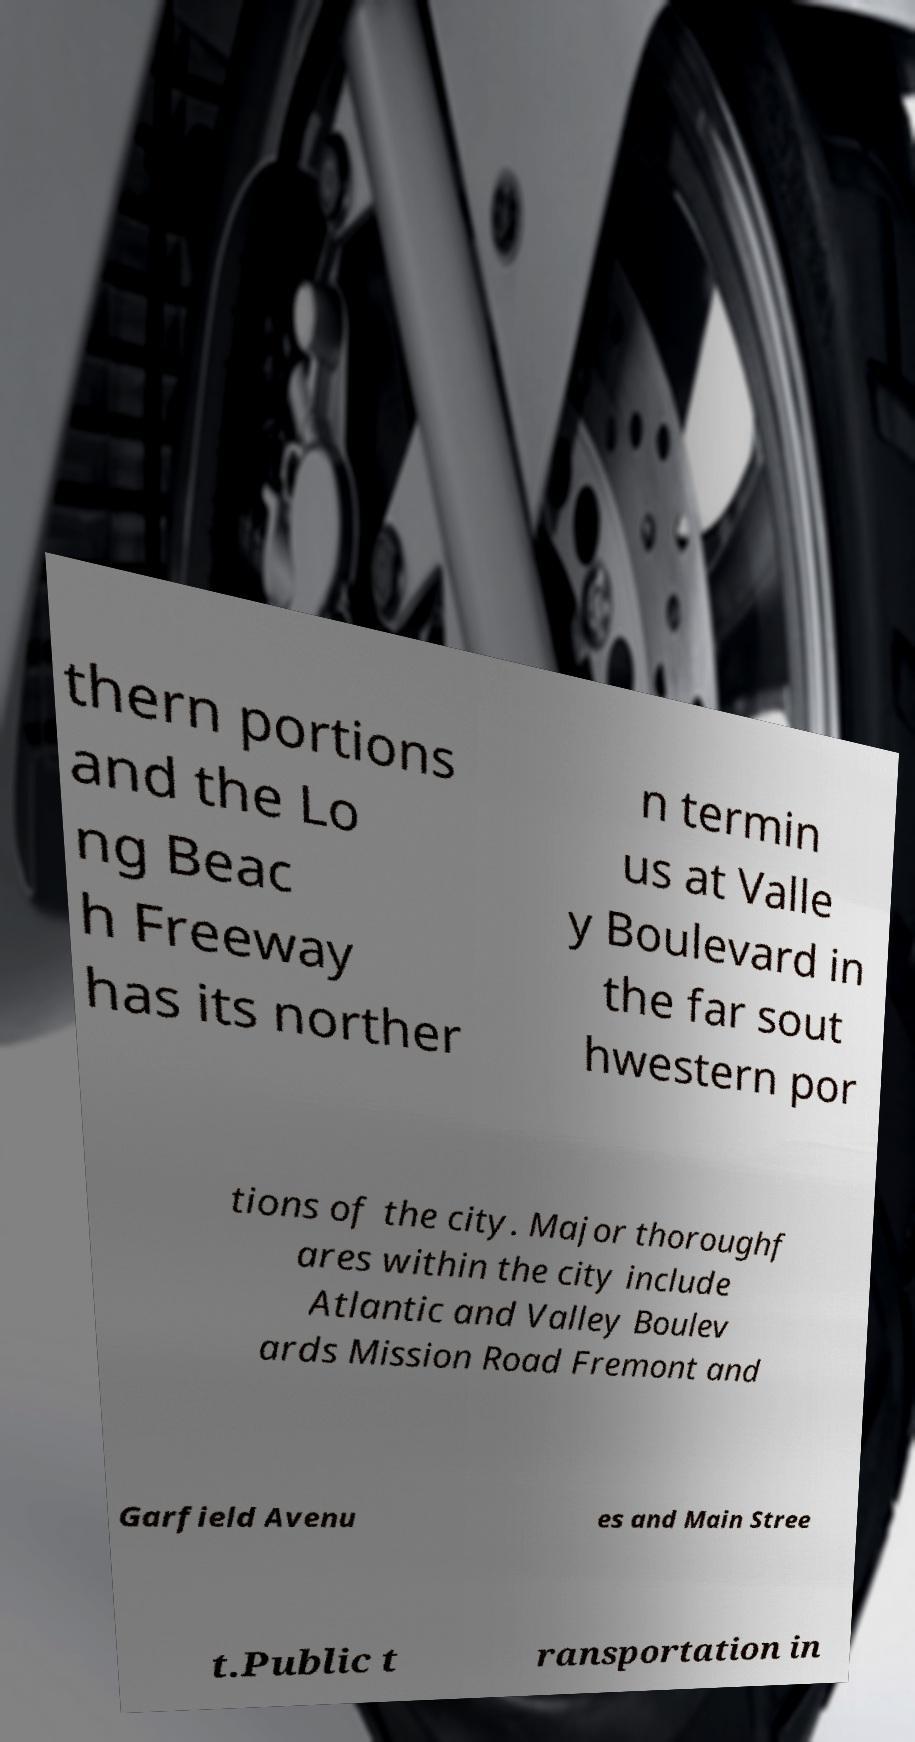For documentation purposes, I need the text within this image transcribed. Could you provide that? thern portions and the Lo ng Beac h Freeway has its norther n termin us at Valle y Boulevard in the far sout hwestern por tions of the city. Major thoroughf ares within the city include Atlantic and Valley Boulev ards Mission Road Fremont and Garfield Avenu es and Main Stree t.Public t ransportation in 